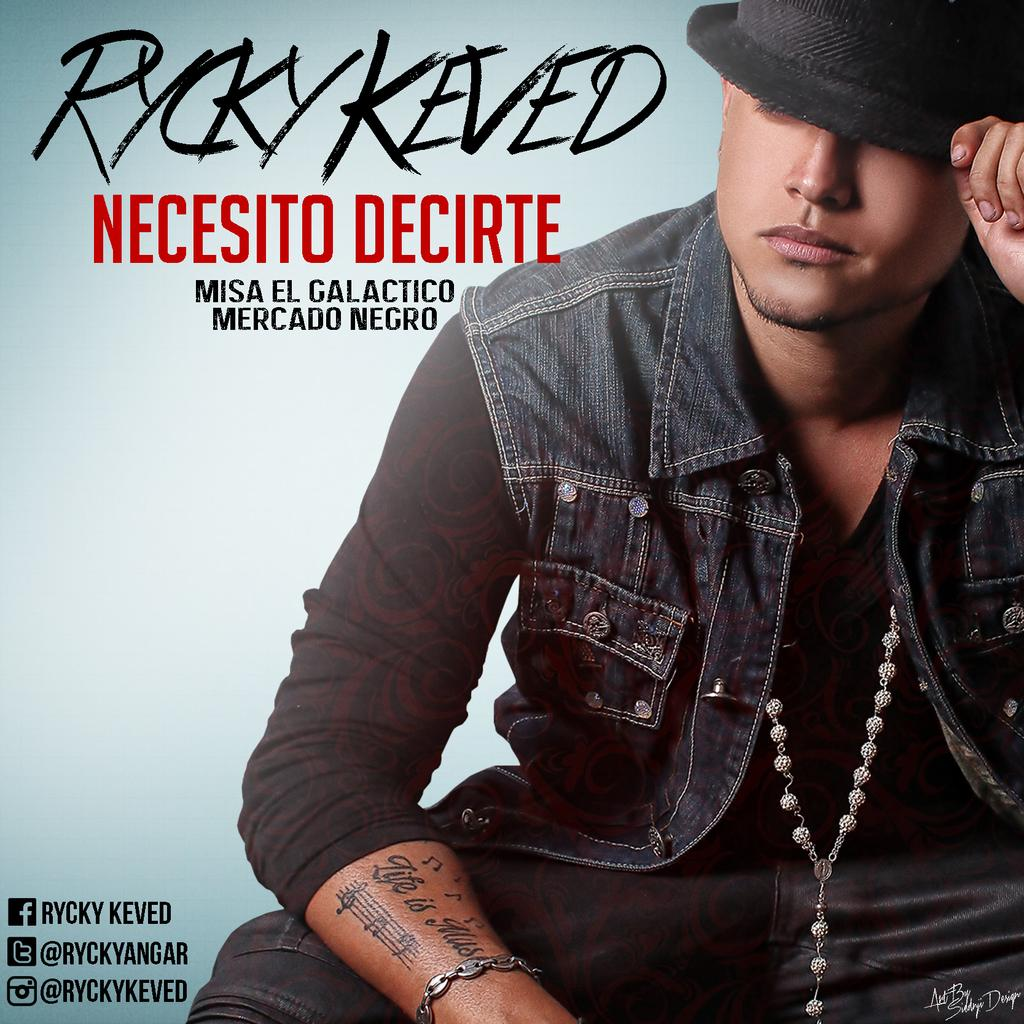Who is in the image? There is a man in the image. What is the man wearing on his head? The man is wearing a black hat. What is the man wearing on his upper body? The man is wearing a black jacket. Can you describe the other object on the man? Unfortunately, the other object on the man is not clearly described in the image. What can be seen in terms of text or symbols in the image? There is some writing visible on the image. How does the man grip the wooden object in the image? There is no wooden object present in the image for the man to grip. 